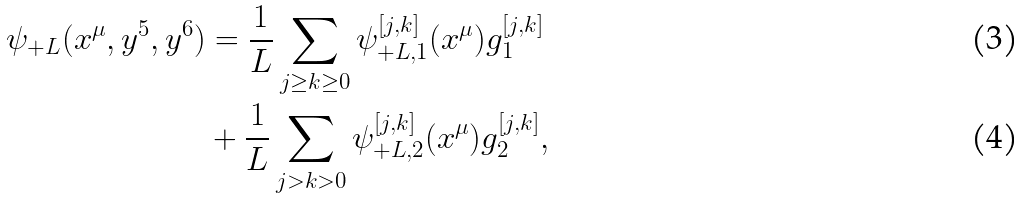<formula> <loc_0><loc_0><loc_500><loc_500>\psi _ { + L } ( x ^ { \mu } , y ^ { 5 } , y ^ { 6 } ) & = \frac { 1 } { L } \sum _ { j \geq k \geq 0 } \psi _ { + L , 1 } ^ { [ j , k ] } ( x ^ { \mu } ) g _ { 1 } ^ { [ j , k ] } \\ & + \frac { 1 } { L } \sum _ { j > k > 0 } \psi _ { + L , 2 } ^ { [ j , k ] } ( x ^ { \mu } ) g _ { 2 } ^ { [ j , k ] } ,</formula> 